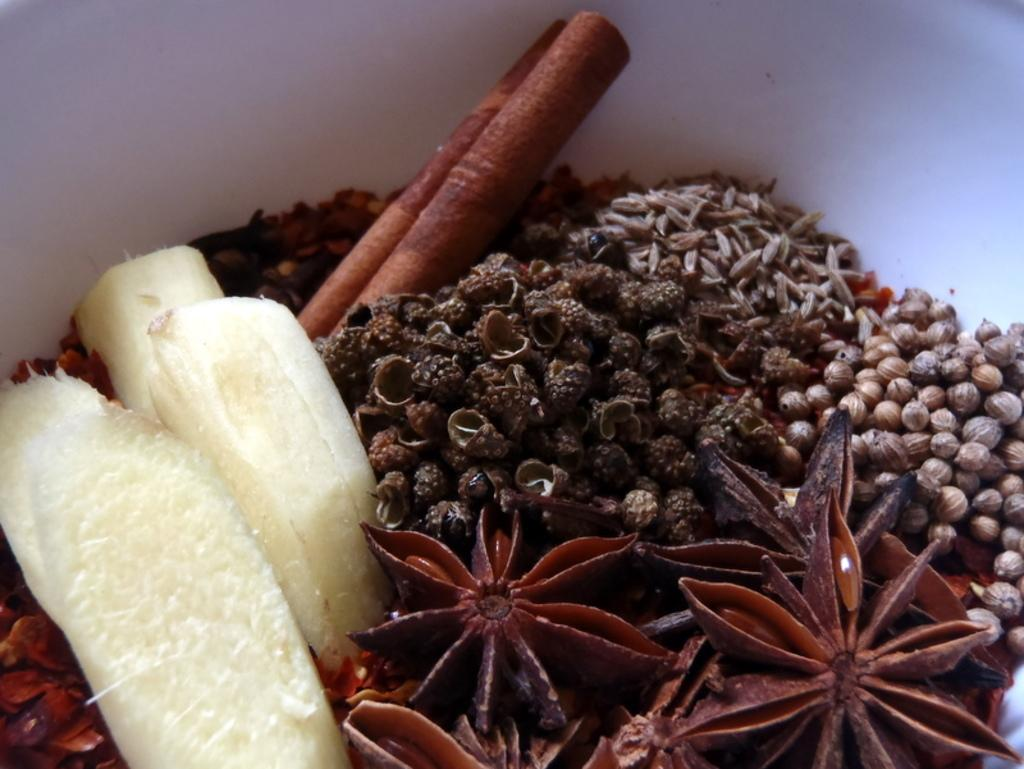What type of spice can be seen in the image? There is cinnamon in the image. What other spice is present in the image? There is star anise in the image. Are there any other spices visible in the image? Yes, there are other spices in the image. Can you tell me how many boys are playing near the crib in the image? There is no boy or crib present in the image; it only features spices. What type of stove is visible in the image? There is no stove present in the image; it only features spices. 